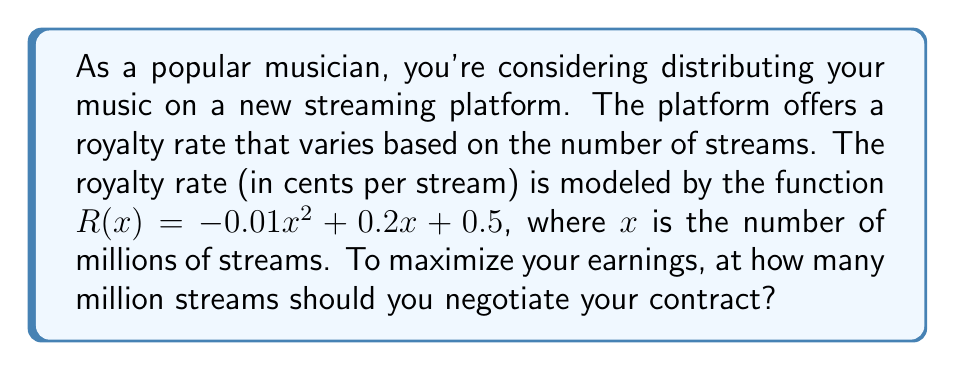Give your solution to this math problem. To find the number of streams that maximizes earnings, we need to find the maximum point of the quadratic function $R(x) = -0.01x^2 + 0.2x + 0.5$.

Step 1: The maximum point of a quadratic function occurs at the vertex. For a quadratic function in the form $f(x) = ax^2 + bx + c$, the x-coordinate of the vertex is given by $x = -\frac{b}{2a}$.

Step 2: In our function, $a = -0.01$ and $b = 0.2$. Let's substitute these values:

$$x = -\frac{0.2}{2(-0.01)} = -\frac{0.2}{-0.02} = 10$$

Step 3: To verify this is a maximum (not a minimum), we can check that $a < 0$, which it is in this case.

Therefore, the royalty rate is maximized when there are 10 million streams.
Answer: 10 million streams 